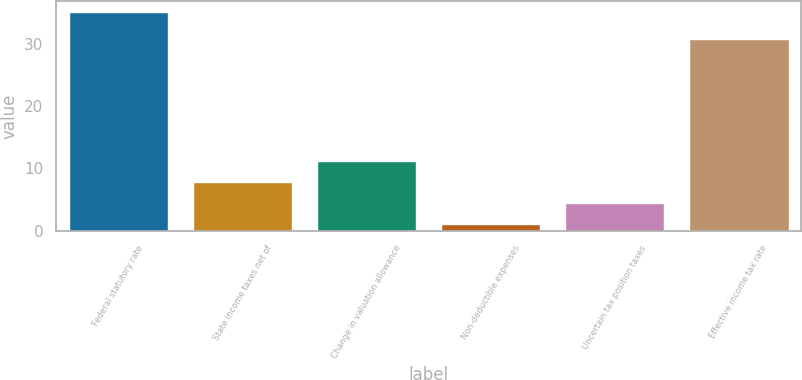Convert chart to OTSL. <chart><loc_0><loc_0><loc_500><loc_500><bar_chart><fcel>Federal statutory rate<fcel>State income taxes net of<fcel>Change in valuation allowance<fcel>Non-deductible expenses<fcel>Uncertain tax position taxes<fcel>Effective income tax rate<nl><fcel>35<fcel>7.8<fcel>11.2<fcel>1<fcel>4.4<fcel>30.8<nl></chart> 